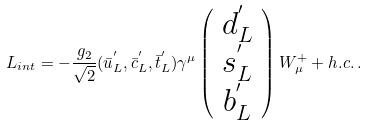<formula> <loc_0><loc_0><loc_500><loc_500>L _ { i n t } = - \frac { g _ { 2 } } { \sqrt { 2 } } ( \bar { u } ^ { ^ { \prime } } _ { L } , \bar { c } ^ { ^ { \prime } } _ { L } , \bar { t } ^ { ^ { \prime } } _ { L } ) \gamma ^ { \mu } \left ( \begin{array} { c c c } d ^ { ^ { \prime } } _ { L } \\ s ^ { ^ { \prime } } _ { L } \\ b ^ { ^ { \prime } } _ { L } \end{array} \right ) W ^ { + } _ { \mu } + h . c . \, .</formula> 